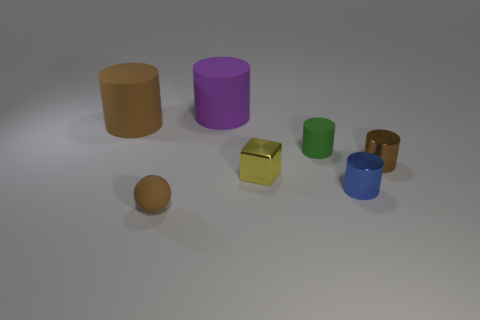Subtract 2 cylinders. How many cylinders are left? 3 Subtract all gray cylinders. Subtract all yellow balls. How many cylinders are left? 5 Add 1 small blue objects. How many objects exist? 8 Subtract all spheres. How many objects are left? 6 Add 2 green metallic cylinders. How many green metallic cylinders exist? 2 Subtract 1 blue cylinders. How many objects are left? 6 Subtract all big shiny cylinders. Subtract all tiny brown rubber balls. How many objects are left? 6 Add 1 green rubber cylinders. How many green rubber cylinders are left? 2 